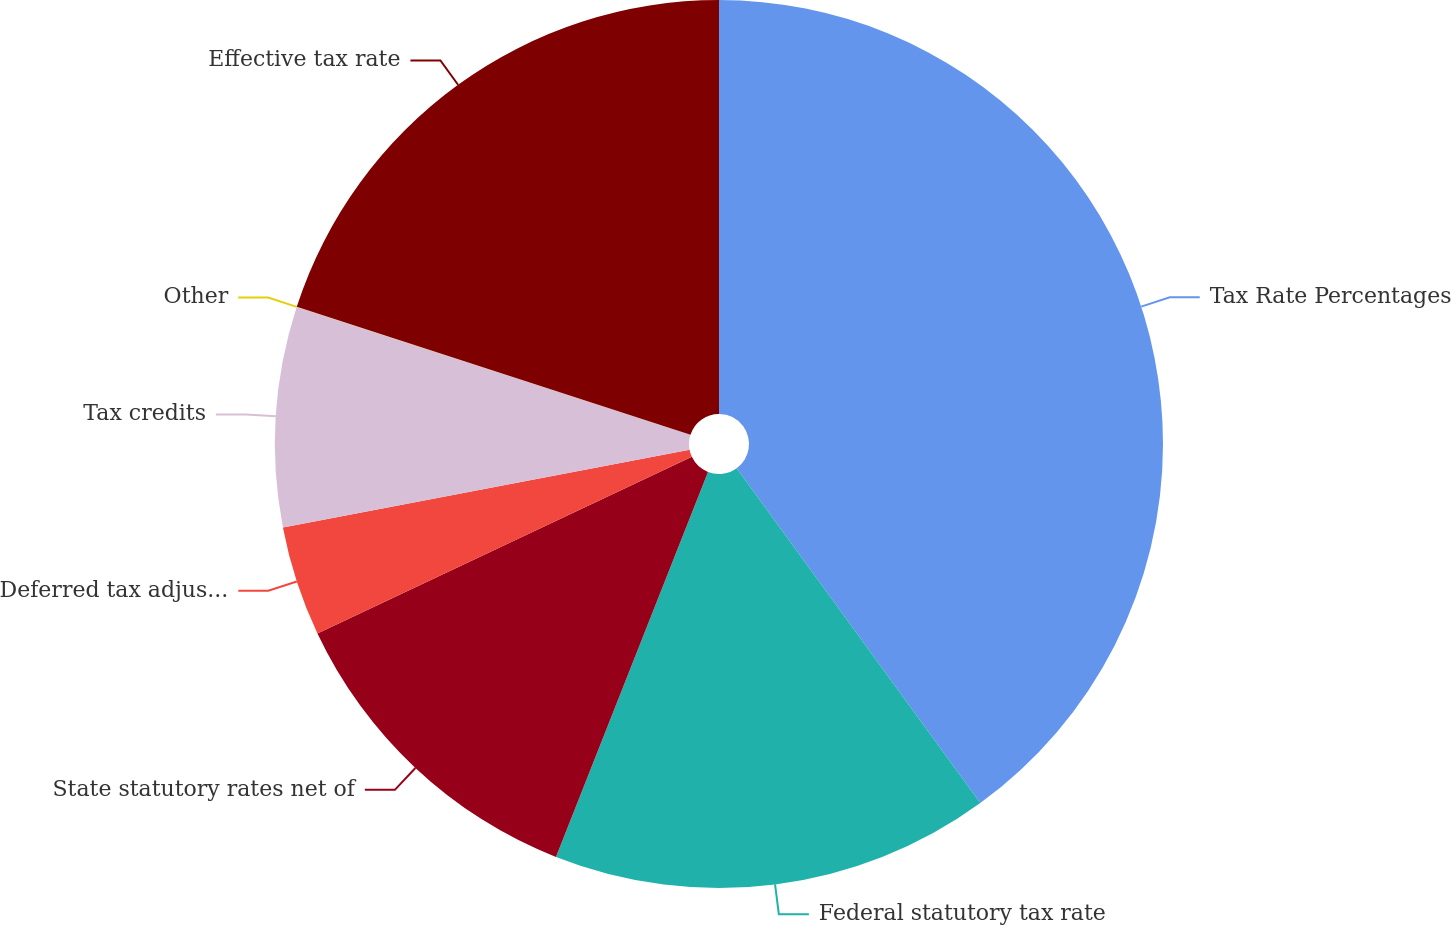Convert chart to OTSL. <chart><loc_0><loc_0><loc_500><loc_500><pie_chart><fcel>Tax Rate Percentages<fcel>Federal statutory tax rate<fcel>State statutory rates net of<fcel>Deferred tax adjustments<fcel>Tax credits<fcel>Other<fcel>Effective tax rate<nl><fcel>39.99%<fcel>16.0%<fcel>12.0%<fcel>4.01%<fcel>8.0%<fcel>0.01%<fcel>20.0%<nl></chart> 